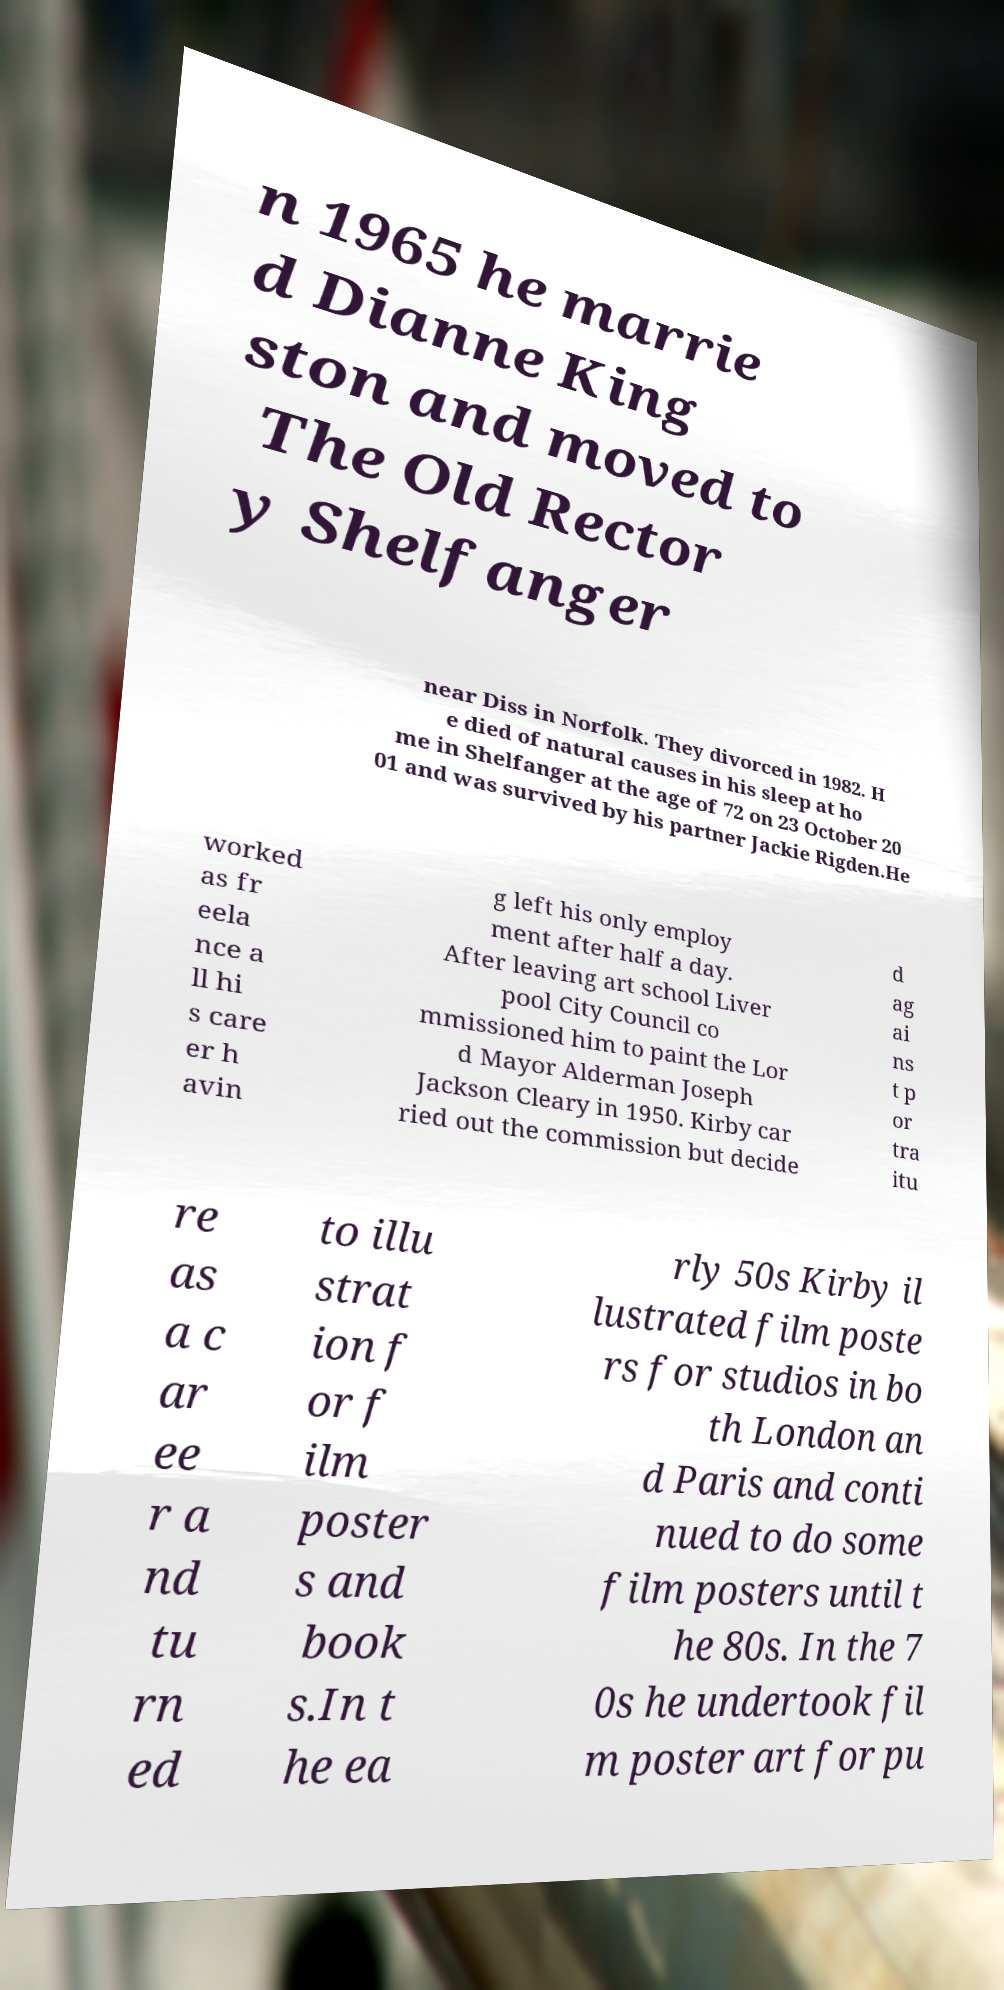For documentation purposes, I need the text within this image transcribed. Could you provide that? n 1965 he marrie d Dianne King ston and moved to The Old Rector y Shelfanger near Diss in Norfolk. They divorced in 1982. H e died of natural causes in his sleep at ho me in Shelfanger at the age of 72 on 23 October 20 01 and was survived by his partner Jackie Rigden.He worked as fr eela nce a ll hi s care er h avin g left his only employ ment after half a day. After leaving art school Liver pool City Council co mmissioned him to paint the Lor d Mayor Alderman Joseph Jackson Cleary in 1950. Kirby car ried out the commission but decide d ag ai ns t p or tra itu re as a c ar ee r a nd tu rn ed to illu strat ion f or f ilm poster s and book s.In t he ea rly 50s Kirby il lustrated film poste rs for studios in bo th London an d Paris and conti nued to do some film posters until t he 80s. In the 7 0s he undertook fil m poster art for pu 